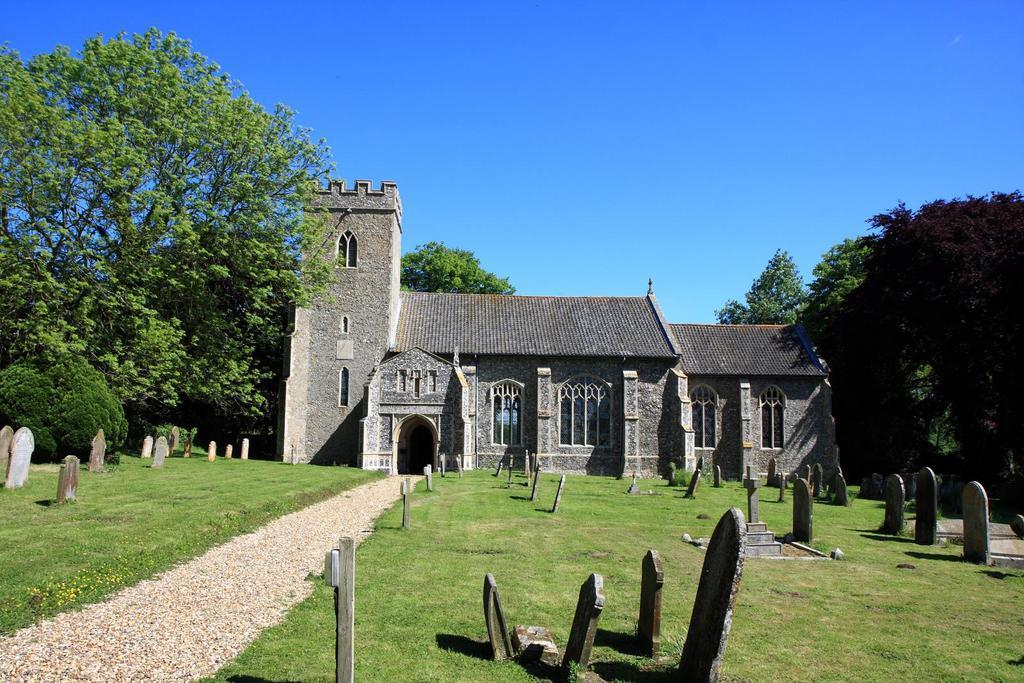Could you give a brief overview of what you see in this image? In this image we can see grave stones on the ground, walking path, building, trees, bushes and sky. 